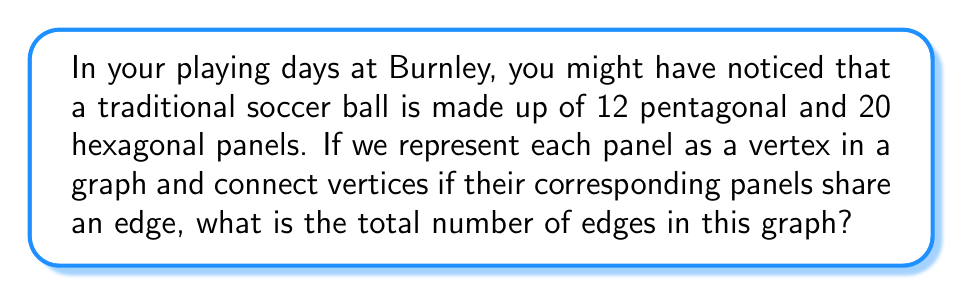Give your solution to this math problem. Let's approach this step-by-step:

1) First, we need to understand what the question is asking. We're creating a graph where:
   - Each vertex represents a panel (12 pentagons + 20 hexagons = 32 vertices)
   - Edges represent shared edges between panels

2) Now, let's count the edges:
   - Each edge of the actual soccer ball is shared by exactly two panels
   - So, the number of edges in our graph will be equal to the total number of edges on the soccer ball

3) To count the edges on the soccer ball:
   - Each pentagon has 5 edges: $5 \times 12 = 60$ edges
   - Each hexagon has 6 edges: $6 \times 20 = 120$ edges
   - Total edges: $60 + 120 = 180$

4) However, this counts each edge twice (once for each panel it's part of)
   So we need to divide by 2:

   $$ \text{Number of edges} = \frac{180}{2} = 90 $$

5) We can verify this using Euler's formula for planar graphs:
   $V - E + F = 2$, where $V$ is vertices, $E$ is edges, and $F$ is faces

   We know:
   $V = 32$ (12 pentagons + 20 hexagons)
   $F = 1$ (the outer face)

   Substituting:
   $32 - E + 1 = 2$
   $E = 31$

   This confirms our calculation of 90 edges.
Answer: 90 